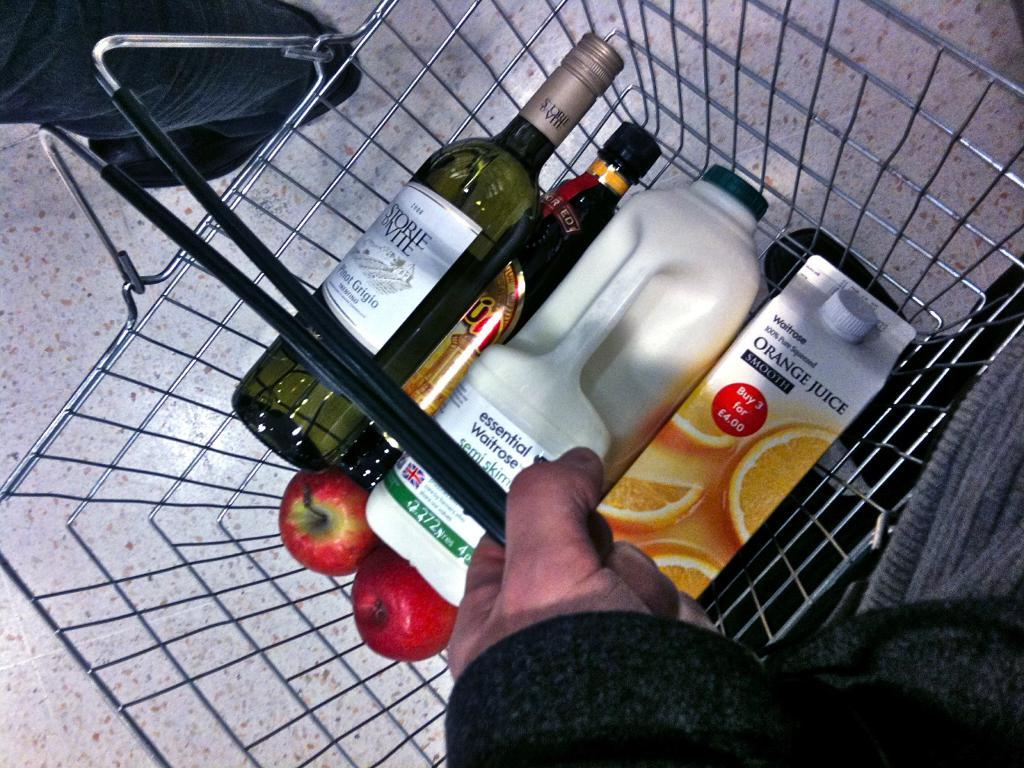<image>
Provide a brief description of the given image. A grocery basket that has milke and a carton that says Orange Juice on it. 